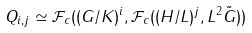<formula> <loc_0><loc_0><loc_500><loc_500>Q _ { i , j } \simeq \mathcal { F } _ { c } ( ( G / K ) ^ { i } , \mathcal { F } _ { c } ( ( H / L ) ^ { j } , L ^ { 2 } \tilde { G } ) )</formula> 